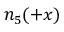<formula> <loc_0><loc_0><loc_500><loc_500>n _ { 5 } ( + x )</formula> 